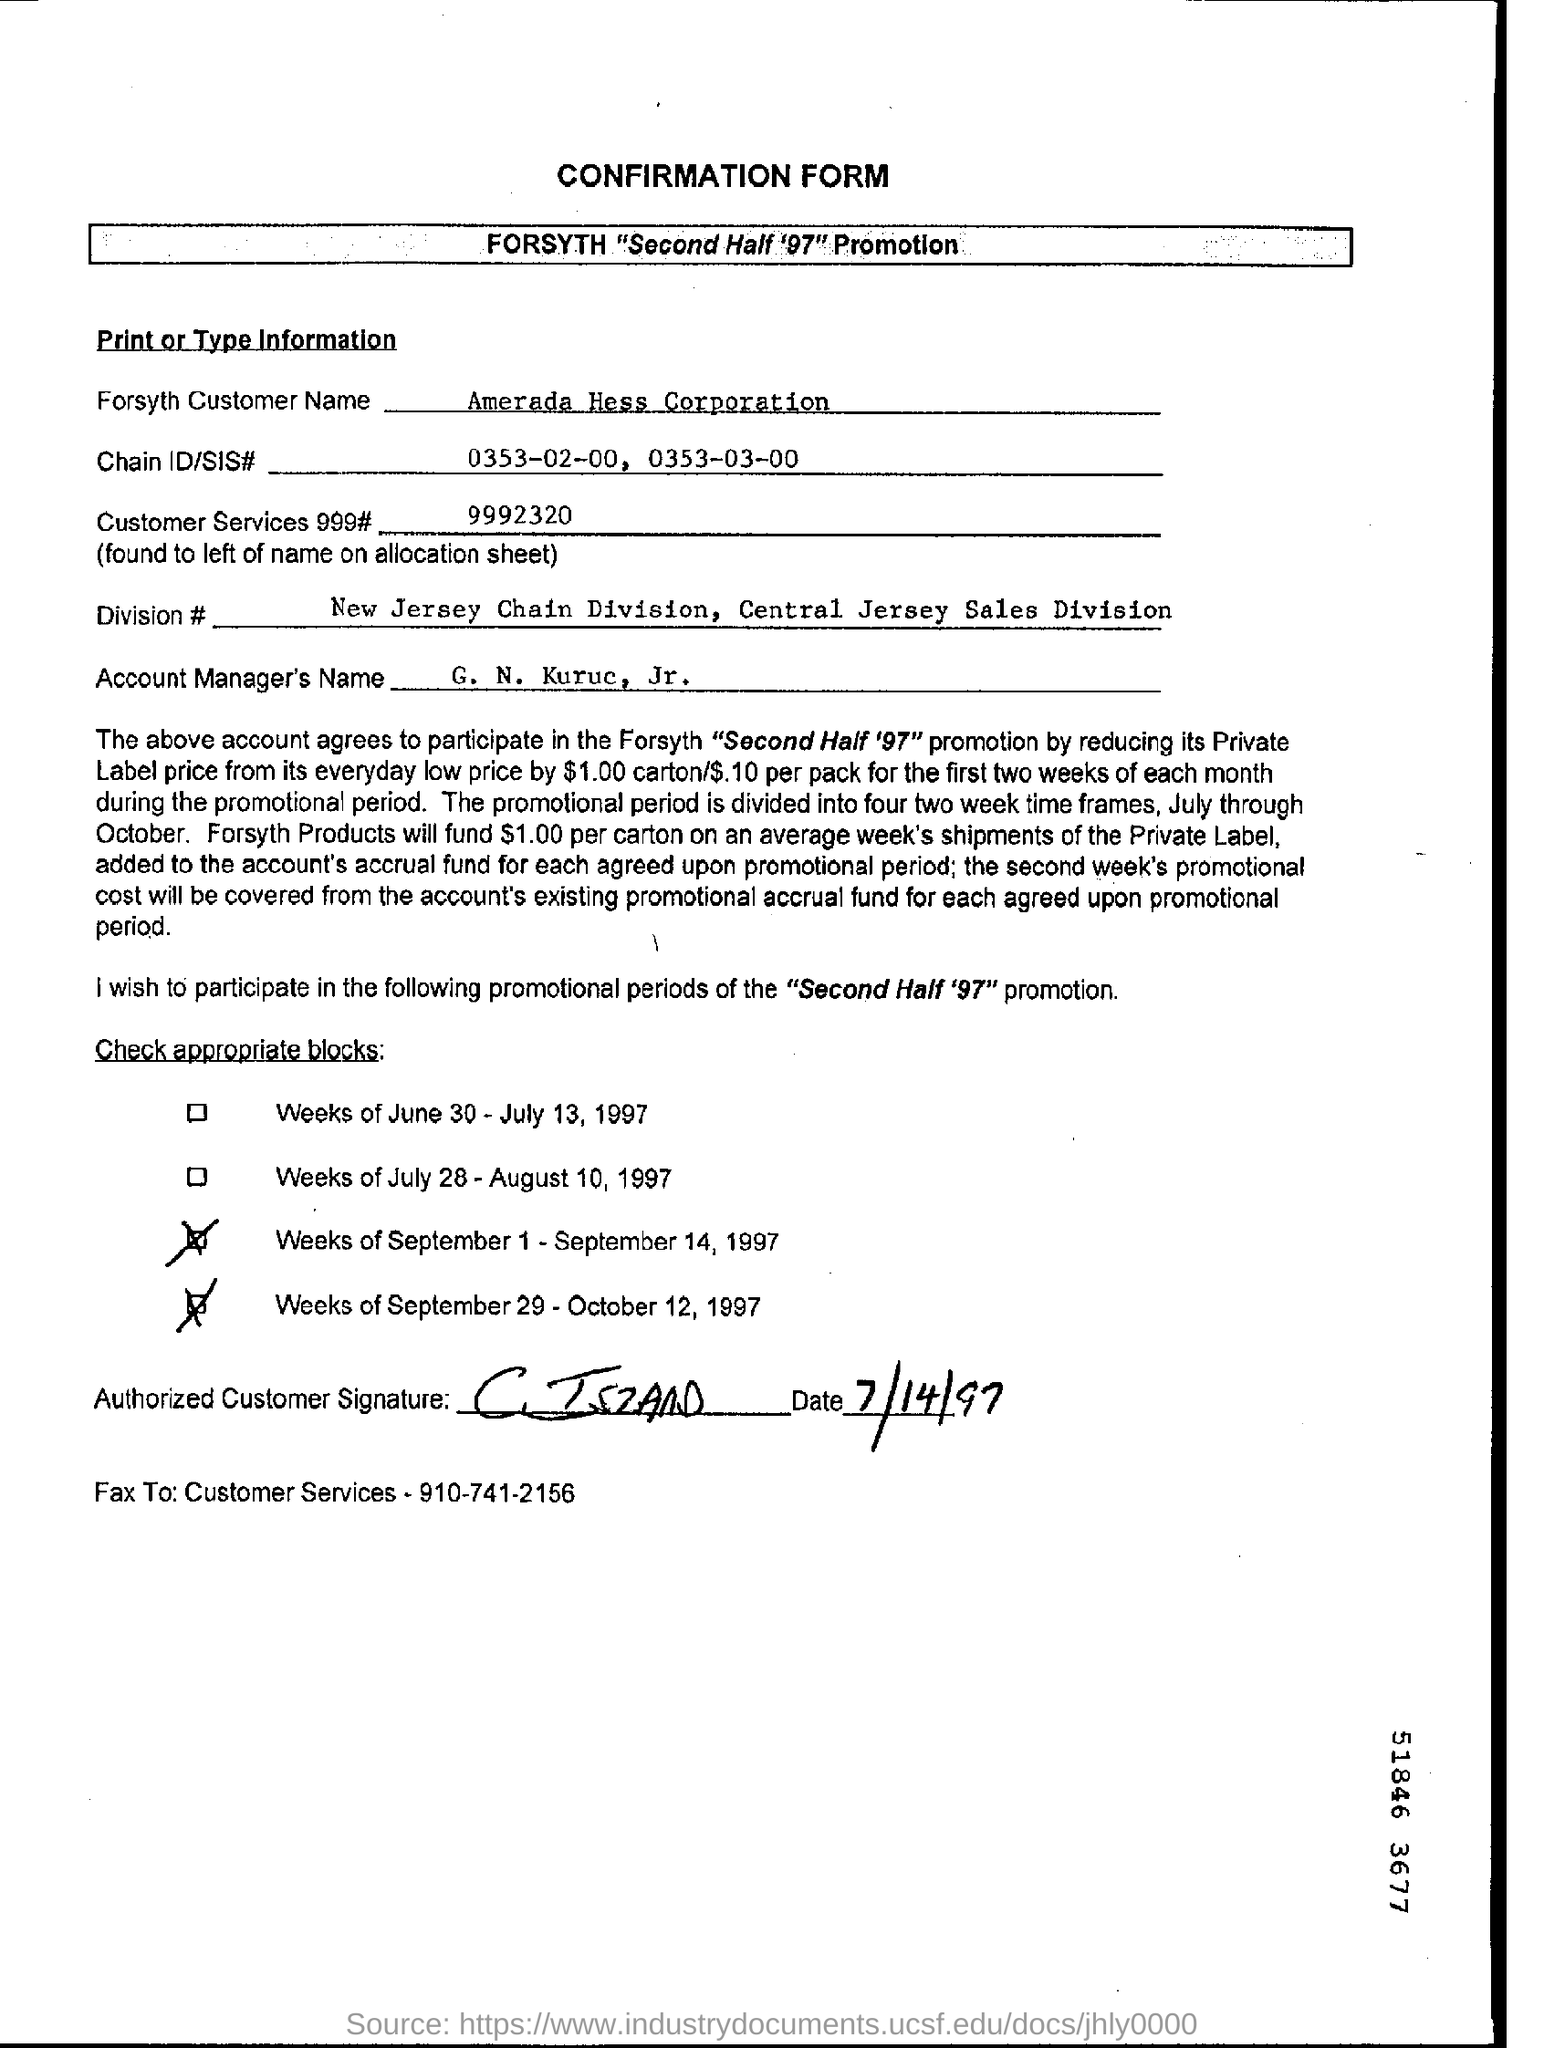Point out several critical features in this image. The customer service 999 number is 999-2320, followed by a series of digits. The customer name is Forsyth, and it is Amerada Hess Corporation. The Chain ID/SIS number is 0353-02-00 and 0353-03-00. The name of the Account Manager is G. N. Kuruc, Jr. 